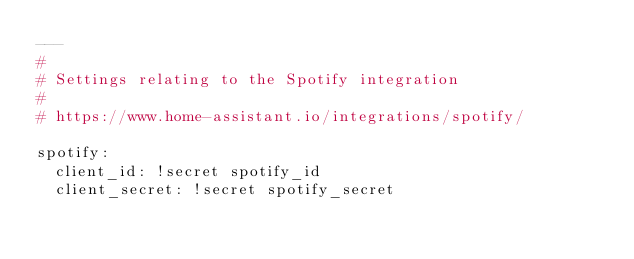Convert code to text. <code><loc_0><loc_0><loc_500><loc_500><_YAML_>---
#  
# Settings relating to the Spotify integration
#
# https://www.home-assistant.io/integrations/spotify/

spotify:
  client_id: !secret spotify_id
  client_secret: !secret spotify_secret</code> 